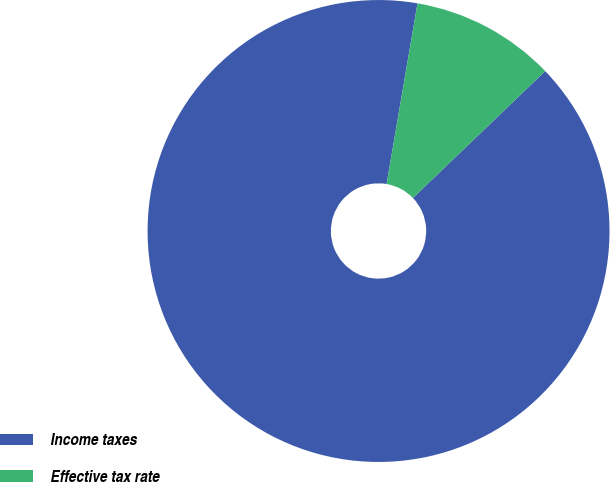Convert chart. <chart><loc_0><loc_0><loc_500><loc_500><pie_chart><fcel>Income taxes<fcel>Effective tax rate<nl><fcel>89.87%<fcel>10.13%<nl></chart> 